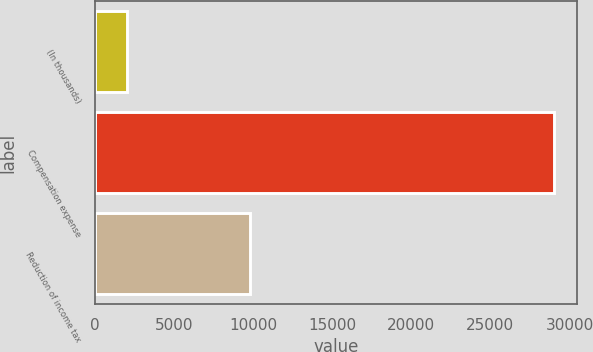<chart> <loc_0><loc_0><loc_500><loc_500><bar_chart><fcel>(In thousands)<fcel>Compensation expense<fcel>Reduction of income tax<nl><fcel>2011<fcel>29019<fcel>9768<nl></chart> 